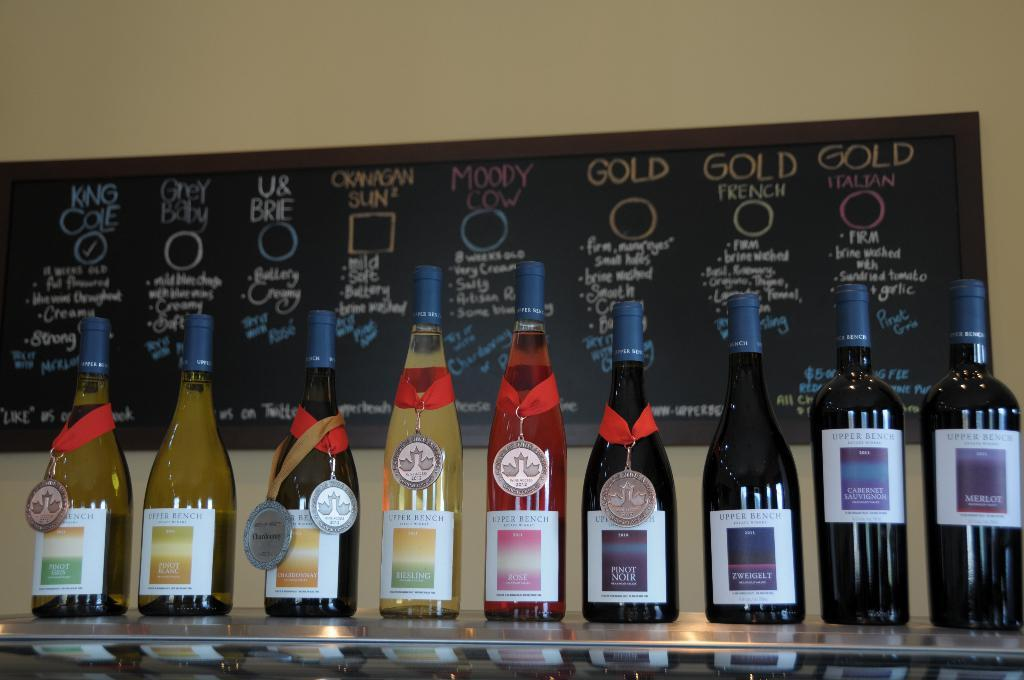<image>
Summarize the visual content of the image. a shelf of alcohol bottles in front of a board that says 'moody cow' and 'gold' and much more 